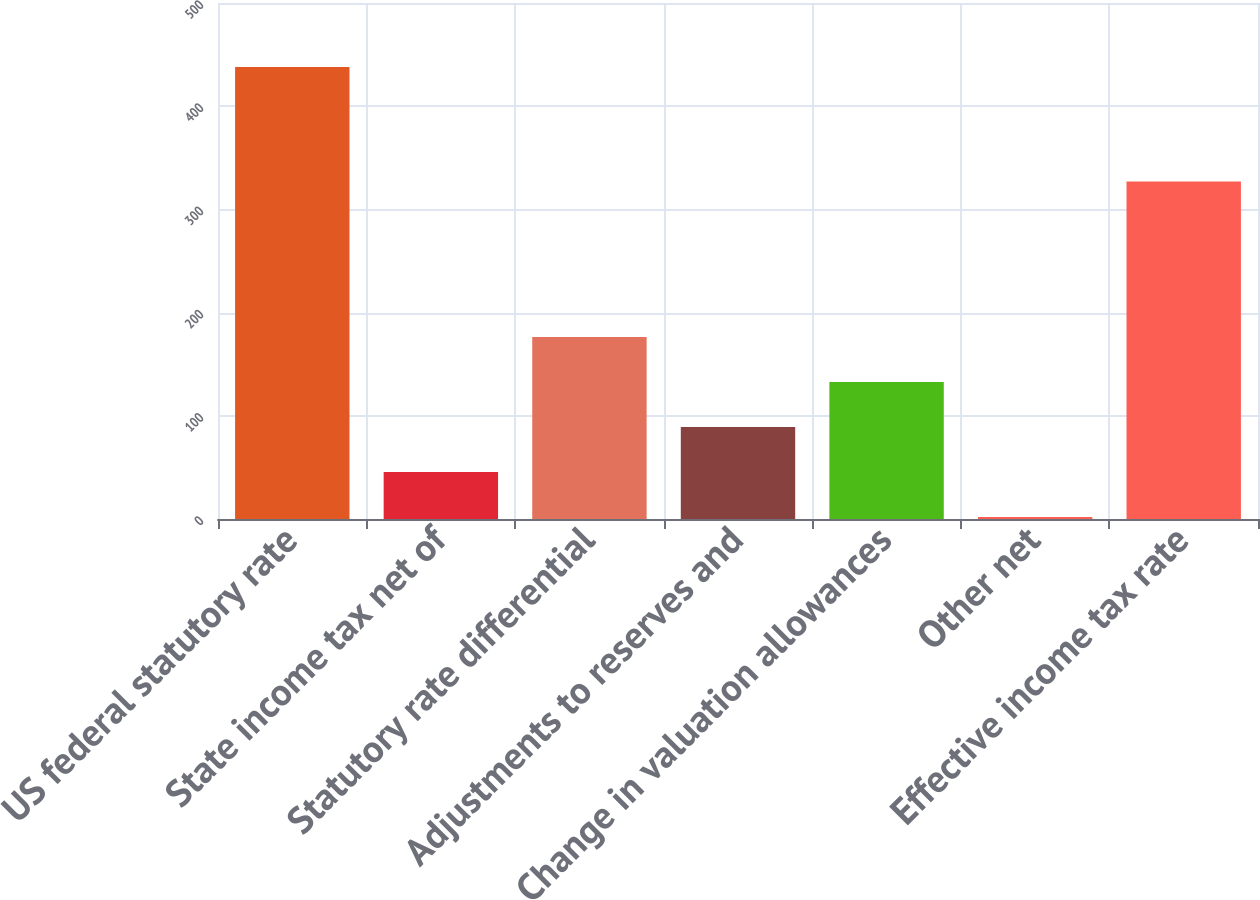Convert chart. <chart><loc_0><loc_0><loc_500><loc_500><bar_chart><fcel>US federal statutory rate<fcel>State income tax net of<fcel>Statutory rate differential<fcel>Adjustments to reserves and<fcel>Change in valuation allowances<fcel>Other net<fcel>Effective income tax rate<nl><fcel>438<fcel>45.6<fcel>176.4<fcel>89.2<fcel>132.8<fcel>2<fcel>327<nl></chart> 